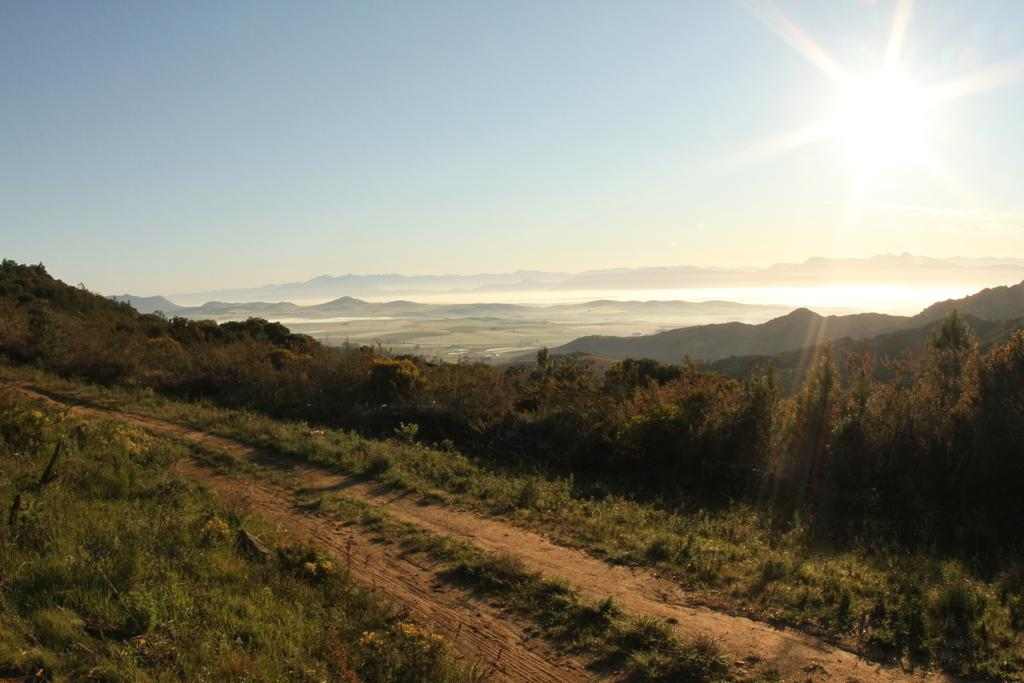What type of vegetation is at the bottom of the image? There are trees and plants at the bottom of the image. What celestial body is visible in the image? The Sun is visible in the image. What natural element is present at the top of the image? The sky is present at the top of the image. Can you see any ghosts interacting with the trees in the image? There are no ghosts present in the image; it features trees and plants. What type of iron structure can be seen in the image? There is no iron structure present in the image. 